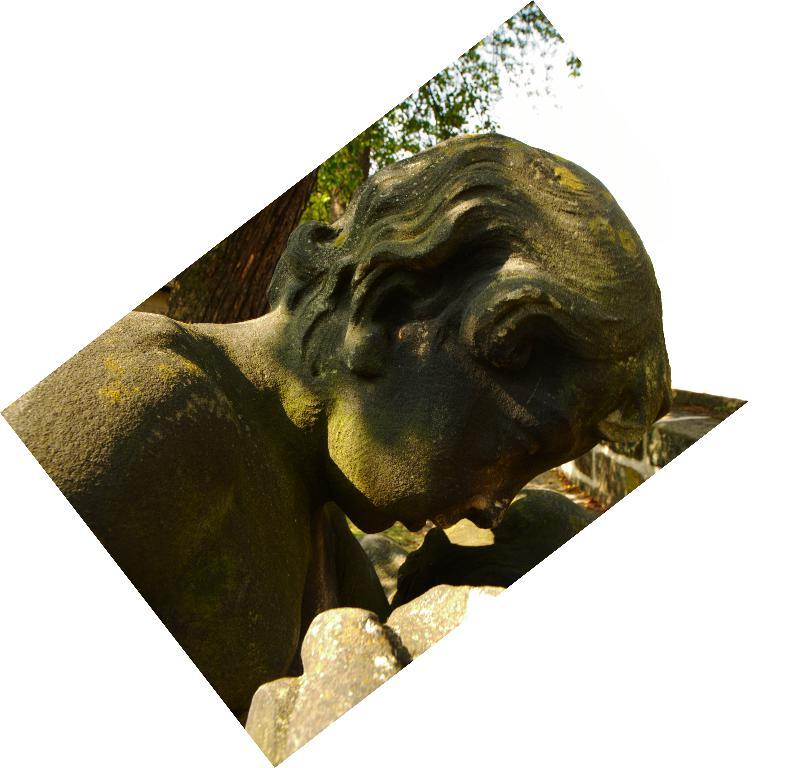What is the main subject of the image? There is a statue of a woman in the image. What can be seen behind the statue? There are trees behind the statue in the image. What type of memory is the statue holding in the image? There is no memory present in the image; it is a statue of a woman with trees in the background. What type of writing can be seen on the statue in the image? There is no writing present on the statue in the image; it is a statue of a woman with trees in the background. 